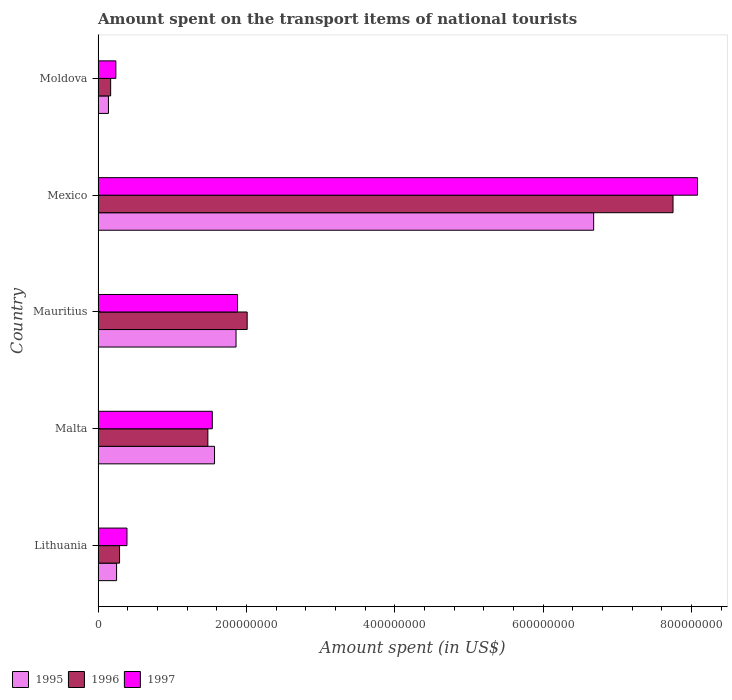How many different coloured bars are there?
Keep it short and to the point. 3. Are the number of bars on each tick of the Y-axis equal?
Offer a very short reply. Yes. How many bars are there on the 1st tick from the bottom?
Offer a very short reply. 3. What is the label of the 4th group of bars from the top?
Offer a terse response. Malta. In how many cases, is the number of bars for a given country not equal to the number of legend labels?
Give a very brief answer. 0. What is the amount spent on the transport items of national tourists in 1997 in Lithuania?
Offer a terse response. 3.90e+07. Across all countries, what is the maximum amount spent on the transport items of national tourists in 1996?
Give a very brief answer. 7.75e+08. Across all countries, what is the minimum amount spent on the transport items of national tourists in 1996?
Your response must be concise. 1.70e+07. In which country was the amount spent on the transport items of national tourists in 1996 minimum?
Your answer should be very brief. Moldova. What is the total amount spent on the transport items of national tourists in 1997 in the graph?
Your answer should be very brief. 1.21e+09. What is the difference between the amount spent on the transport items of national tourists in 1995 in Lithuania and that in Mauritius?
Ensure brevity in your answer.  -1.61e+08. What is the difference between the amount spent on the transport items of national tourists in 1997 in Malta and the amount spent on the transport items of national tourists in 1995 in Lithuania?
Ensure brevity in your answer.  1.29e+08. What is the average amount spent on the transport items of national tourists in 1996 per country?
Give a very brief answer. 2.34e+08. What is the difference between the amount spent on the transport items of national tourists in 1996 and amount spent on the transport items of national tourists in 1997 in Lithuania?
Provide a succinct answer. -1.00e+07. What is the ratio of the amount spent on the transport items of national tourists in 1995 in Malta to that in Moldova?
Offer a very short reply. 11.21. Is the difference between the amount spent on the transport items of national tourists in 1996 in Lithuania and Mexico greater than the difference between the amount spent on the transport items of national tourists in 1997 in Lithuania and Mexico?
Your answer should be compact. Yes. What is the difference between the highest and the second highest amount spent on the transport items of national tourists in 1997?
Your answer should be very brief. 6.20e+08. What is the difference between the highest and the lowest amount spent on the transport items of national tourists in 1997?
Provide a succinct answer. 7.84e+08. In how many countries, is the amount spent on the transport items of national tourists in 1996 greater than the average amount spent on the transport items of national tourists in 1996 taken over all countries?
Offer a very short reply. 1. What does the 3rd bar from the top in Mexico represents?
Make the answer very short. 1995. How many bars are there?
Provide a succinct answer. 15. Are all the bars in the graph horizontal?
Provide a short and direct response. Yes. How many countries are there in the graph?
Keep it short and to the point. 5. Are the values on the major ticks of X-axis written in scientific E-notation?
Make the answer very short. No. Where does the legend appear in the graph?
Your response must be concise. Bottom left. How many legend labels are there?
Keep it short and to the point. 3. What is the title of the graph?
Keep it short and to the point. Amount spent on the transport items of national tourists. What is the label or title of the X-axis?
Keep it short and to the point. Amount spent (in US$). What is the label or title of the Y-axis?
Your answer should be very brief. Country. What is the Amount spent (in US$) of 1995 in Lithuania?
Your answer should be compact. 2.50e+07. What is the Amount spent (in US$) of 1996 in Lithuania?
Offer a very short reply. 2.90e+07. What is the Amount spent (in US$) in 1997 in Lithuania?
Offer a very short reply. 3.90e+07. What is the Amount spent (in US$) of 1995 in Malta?
Your answer should be compact. 1.57e+08. What is the Amount spent (in US$) of 1996 in Malta?
Your response must be concise. 1.48e+08. What is the Amount spent (in US$) in 1997 in Malta?
Offer a terse response. 1.54e+08. What is the Amount spent (in US$) of 1995 in Mauritius?
Keep it short and to the point. 1.86e+08. What is the Amount spent (in US$) in 1996 in Mauritius?
Your answer should be very brief. 2.01e+08. What is the Amount spent (in US$) of 1997 in Mauritius?
Offer a very short reply. 1.88e+08. What is the Amount spent (in US$) in 1995 in Mexico?
Your answer should be very brief. 6.68e+08. What is the Amount spent (in US$) of 1996 in Mexico?
Your response must be concise. 7.75e+08. What is the Amount spent (in US$) in 1997 in Mexico?
Keep it short and to the point. 8.08e+08. What is the Amount spent (in US$) in 1995 in Moldova?
Keep it short and to the point. 1.40e+07. What is the Amount spent (in US$) in 1996 in Moldova?
Keep it short and to the point. 1.70e+07. What is the Amount spent (in US$) in 1997 in Moldova?
Keep it short and to the point. 2.40e+07. Across all countries, what is the maximum Amount spent (in US$) in 1995?
Ensure brevity in your answer.  6.68e+08. Across all countries, what is the maximum Amount spent (in US$) in 1996?
Keep it short and to the point. 7.75e+08. Across all countries, what is the maximum Amount spent (in US$) in 1997?
Ensure brevity in your answer.  8.08e+08. Across all countries, what is the minimum Amount spent (in US$) in 1995?
Your response must be concise. 1.40e+07. Across all countries, what is the minimum Amount spent (in US$) in 1996?
Your response must be concise. 1.70e+07. Across all countries, what is the minimum Amount spent (in US$) in 1997?
Make the answer very short. 2.40e+07. What is the total Amount spent (in US$) of 1995 in the graph?
Offer a very short reply. 1.05e+09. What is the total Amount spent (in US$) in 1996 in the graph?
Ensure brevity in your answer.  1.17e+09. What is the total Amount spent (in US$) of 1997 in the graph?
Keep it short and to the point. 1.21e+09. What is the difference between the Amount spent (in US$) of 1995 in Lithuania and that in Malta?
Offer a very short reply. -1.32e+08. What is the difference between the Amount spent (in US$) in 1996 in Lithuania and that in Malta?
Offer a terse response. -1.19e+08. What is the difference between the Amount spent (in US$) of 1997 in Lithuania and that in Malta?
Give a very brief answer. -1.15e+08. What is the difference between the Amount spent (in US$) of 1995 in Lithuania and that in Mauritius?
Offer a terse response. -1.61e+08. What is the difference between the Amount spent (in US$) in 1996 in Lithuania and that in Mauritius?
Ensure brevity in your answer.  -1.72e+08. What is the difference between the Amount spent (in US$) of 1997 in Lithuania and that in Mauritius?
Your answer should be very brief. -1.49e+08. What is the difference between the Amount spent (in US$) of 1995 in Lithuania and that in Mexico?
Provide a succinct answer. -6.43e+08. What is the difference between the Amount spent (in US$) in 1996 in Lithuania and that in Mexico?
Offer a terse response. -7.46e+08. What is the difference between the Amount spent (in US$) of 1997 in Lithuania and that in Mexico?
Your answer should be very brief. -7.69e+08. What is the difference between the Amount spent (in US$) of 1995 in Lithuania and that in Moldova?
Offer a very short reply. 1.10e+07. What is the difference between the Amount spent (in US$) in 1997 in Lithuania and that in Moldova?
Your answer should be very brief. 1.50e+07. What is the difference between the Amount spent (in US$) of 1995 in Malta and that in Mauritius?
Make the answer very short. -2.90e+07. What is the difference between the Amount spent (in US$) in 1996 in Malta and that in Mauritius?
Ensure brevity in your answer.  -5.30e+07. What is the difference between the Amount spent (in US$) of 1997 in Malta and that in Mauritius?
Give a very brief answer. -3.40e+07. What is the difference between the Amount spent (in US$) in 1995 in Malta and that in Mexico?
Keep it short and to the point. -5.11e+08. What is the difference between the Amount spent (in US$) in 1996 in Malta and that in Mexico?
Offer a terse response. -6.27e+08. What is the difference between the Amount spent (in US$) in 1997 in Malta and that in Mexico?
Offer a very short reply. -6.54e+08. What is the difference between the Amount spent (in US$) of 1995 in Malta and that in Moldova?
Offer a very short reply. 1.43e+08. What is the difference between the Amount spent (in US$) of 1996 in Malta and that in Moldova?
Your answer should be very brief. 1.31e+08. What is the difference between the Amount spent (in US$) of 1997 in Malta and that in Moldova?
Provide a succinct answer. 1.30e+08. What is the difference between the Amount spent (in US$) of 1995 in Mauritius and that in Mexico?
Give a very brief answer. -4.82e+08. What is the difference between the Amount spent (in US$) of 1996 in Mauritius and that in Mexico?
Your answer should be compact. -5.74e+08. What is the difference between the Amount spent (in US$) in 1997 in Mauritius and that in Mexico?
Offer a terse response. -6.20e+08. What is the difference between the Amount spent (in US$) in 1995 in Mauritius and that in Moldova?
Your response must be concise. 1.72e+08. What is the difference between the Amount spent (in US$) of 1996 in Mauritius and that in Moldova?
Give a very brief answer. 1.84e+08. What is the difference between the Amount spent (in US$) of 1997 in Mauritius and that in Moldova?
Your response must be concise. 1.64e+08. What is the difference between the Amount spent (in US$) of 1995 in Mexico and that in Moldova?
Make the answer very short. 6.54e+08. What is the difference between the Amount spent (in US$) of 1996 in Mexico and that in Moldova?
Give a very brief answer. 7.58e+08. What is the difference between the Amount spent (in US$) of 1997 in Mexico and that in Moldova?
Your answer should be very brief. 7.84e+08. What is the difference between the Amount spent (in US$) of 1995 in Lithuania and the Amount spent (in US$) of 1996 in Malta?
Give a very brief answer. -1.23e+08. What is the difference between the Amount spent (in US$) in 1995 in Lithuania and the Amount spent (in US$) in 1997 in Malta?
Give a very brief answer. -1.29e+08. What is the difference between the Amount spent (in US$) of 1996 in Lithuania and the Amount spent (in US$) of 1997 in Malta?
Keep it short and to the point. -1.25e+08. What is the difference between the Amount spent (in US$) of 1995 in Lithuania and the Amount spent (in US$) of 1996 in Mauritius?
Your answer should be compact. -1.76e+08. What is the difference between the Amount spent (in US$) of 1995 in Lithuania and the Amount spent (in US$) of 1997 in Mauritius?
Provide a short and direct response. -1.63e+08. What is the difference between the Amount spent (in US$) in 1996 in Lithuania and the Amount spent (in US$) in 1997 in Mauritius?
Provide a short and direct response. -1.59e+08. What is the difference between the Amount spent (in US$) in 1995 in Lithuania and the Amount spent (in US$) in 1996 in Mexico?
Ensure brevity in your answer.  -7.50e+08. What is the difference between the Amount spent (in US$) of 1995 in Lithuania and the Amount spent (in US$) of 1997 in Mexico?
Your answer should be very brief. -7.83e+08. What is the difference between the Amount spent (in US$) of 1996 in Lithuania and the Amount spent (in US$) of 1997 in Mexico?
Your answer should be compact. -7.79e+08. What is the difference between the Amount spent (in US$) of 1995 in Lithuania and the Amount spent (in US$) of 1996 in Moldova?
Offer a terse response. 8.00e+06. What is the difference between the Amount spent (in US$) in 1996 in Lithuania and the Amount spent (in US$) in 1997 in Moldova?
Keep it short and to the point. 5.00e+06. What is the difference between the Amount spent (in US$) in 1995 in Malta and the Amount spent (in US$) in 1996 in Mauritius?
Provide a succinct answer. -4.40e+07. What is the difference between the Amount spent (in US$) of 1995 in Malta and the Amount spent (in US$) of 1997 in Mauritius?
Make the answer very short. -3.10e+07. What is the difference between the Amount spent (in US$) of 1996 in Malta and the Amount spent (in US$) of 1997 in Mauritius?
Provide a succinct answer. -4.00e+07. What is the difference between the Amount spent (in US$) of 1995 in Malta and the Amount spent (in US$) of 1996 in Mexico?
Give a very brief answer. -6.18e+08. What is the difference between the Amount spent (in US$) in 1995 in Malta and the Amount spent (in US$) in 1997 in Mexico?
Offer a terse response. -6.51e+08. What is the difference between the Amount spent (in US$) of 1996 in Malta and the Amount spent (in US$) of 1997 in Mexico?
Offer a terse response. -6.60e+08. What is the difference between the Amount spent (in US$) of 1995 in Malta and the Amount spent (in US$) of 1996 in Moldova?
Offer a terse response. 1.40e+08. What is the difference between the Amount spent (in US$) in 1995 in Malta and the Amount spent (in US$) in 1997 in Moldova?
Offer a terse response. 1.33e+08. What is the difference between the Amount spent (in US$) of 1996 in Malta and the Amount spent (in US$) of 1997 in Moldova?
Make the answer very short. 1.24e+08. What is the difference between the Amount spent (in US$) in 1995 in Mauritius and the Amount spent (in US$) in 1996 in Mexico?
Offer a very short reply. -5.89e+08. What is the difference between the Amount spent (in US$) of 1995 in Mauritius and the Amount spent (in US$) of 1997 in Mexico?
Offer a terse response. -6.22e+08. What is the difference between the Amount spent (in US$) in 1996 in Mauritius and the Amount spent (in US$) in 1997 in Mexico?
Provide a short and direct response. -6.07e+08. What is the difference between the Amount spent (in US$) of 1995 in Mauritius and the Amount spent (in US$) of 1996 in Moldova?
Give a very brief answer. 1.69e+08. What is the difference between the Amount spent (in US$) in 1995 in Mauritius and the Amount spent (in US$) in 1997 in Moldova?
Provide a succinct answer. 1.62e+08. What is the difference between the Amount spent (in US$) of 1996 in Mauritius and the Amount spent (in US$) of 1997 in Moldova?
Your answer should be compact. 1.77e+08. What is the difference between the Amount spent (in US$) of 1995 in Mexico and the Amount spent (in US$) of 1996 in Moldova?
Provide a succinct answer. 6.51e+08. What is the difference between the Amount spent (in US$) of 1995 in Mexico and the Amount spent (in US$) of 1997 in Moldova?
Your answer should be very brief. 6.44e+08. What is the difference between the Amount spent (in US$) of 1996 in Mexico and the Amount spent (in US$) of 1997 in Moldova?
Provide a succinct answer. 7.51e+08. What is the average Amount spent (in US$) in 1995 per country?
Make the answer very short. 2.10e+08. What is the average Amount spent (in US$) in 1996 per country?
Your answer should be very brief. 2.34e+08. What is the average Amount spent (in US$) of 1997 per country?
Give a very brief answer. 2.43e+08. What is the difference between the Amount spent (in US$) in 1995 and Amount spent (in US$) in 1997 in Lithuania?
Make the answer very short. -1.40e+07. What is the difference between the Amount spent (in US$) of 1996 and Amount spent (in US$) of 1997 in Lithuania?
Your answer should be very brief. -1.00e+07. What is the difference between the Amount spent (in US$) of 1995 and Amount spent (in US$) of 1996 in Malta?
Give a very brief answer. 9.00e+06. What is the difference between the Amount spent (in US$) of 1995 and Amount spent (in US$) of 1997 in Malta?
Offer a terse response. 3.00e+06. What is the difference between the Amount spent (in US$) in 1996 and Amount spent (in US$) in 1997 in Malta?
Your response must be concise. -6.00e+06. What is the difference between the Amount spent (in US$) in 1995 and Amount spent (in US$) in 1996 in Mauritius?
Your answer should be very brief. -1.50e+07. What is the difference between the Amount spent (in US$) of 1995 and Amount spent (in US$) of 1997 in Mauritius?
Provide a short and direct response. -2.00e+06. What is the difference between the Amount spent (in US$) of 1996 and Amount spent (in US$) of 1997 in Mauritius?
Your response must be concise. 1.30e+07. What is the difference between the Amount spent (in US$) of 1995 and Amount spent (in US$) of 1996 in Mexico?
Provide a short and direct response. -1.07e+08. What is the difference between the Amount spent (in US$) of 1995 and Amount spent (in US$) of 1997 in Mexico?
Your answer should be compact. -1.40e+08. What is the difference between the Amount spent (in US$) of 1996 and Amount spent (in US$) of 1997 in Mexico?
Make the answer very short. -3.30e+07. What is the difference between the Amount spent (in US$) of 1995 and Amount spent (in US$) of 1996 in Moldova?
Your response must be concise. -3.00e+06. What is the difference between the Amount spent (in US$) in 1995 and Amount spent (in US$) in 1997 in Moldova?
Your answer should be very brief. -1.00e+07. What is the difference between the Amount spent (in US$) of 1996 and Amount spent (in US$) of 1997 in Moldova?
Provide a short and direct response. -7.00e+06. What is the ratio of the Amount spent (in US$) of 1995 in Lithuania to that in Malta?
Offer a very short reply. 0.16. What is the ratio of the Amount spent (in US$) in 1996 in Lithuania to that in Malta?
Offer a terse response. 0.2. What is the ratio of the Amount spent (in US$) of 1997 in Lithuania to that in Malta?
Make the answer very short. 0.25. What is the ratio of the Amount spent (in US$) in 1995 in Lithuania to that in Mauritius?
Make the answer very short. 0.13. What is the ratio of the Amount spent (in US$) of 1996 in Lithuania to that in Mauritius?
Provide a short and direct response. 0.14. What is the ratio of the Amount spent (in US$) of 1997 in Lithuania to that in Mauritius?
Provide a short and direct response. 0.21. What is the ratio of the Amount spent (in US$) in 1995 in Lithuania to that in Mexico?
Keep it short and to the point. 0.04. What is the ratio of the Amount spent (in US$) in 1996 in Lithuania to that in Mexico?
Make the answer very short. 0.04. What is the ratio of the Amount spent (in US$) of 1997 in Lithuania to that in Mexico?
Provide a succinct answer. 0.05. What is the ratio of the Amount spent (in US$) in 1995 in Lithuania to that in Moldova?
Your answer should be compact. 1.79. What is the ratio of the Amount spent (in US$) of 1996 in Lithuania to that in Moldova?
Your response must be concise. 1.71. What is the ratio of the Amount spent (in US$) of 1997 in Lithuania to that in Moldova?
Offer a terse response. 1.62. What is the ratio of the Amount spent (in US$) in 1995 in Malta to that in Mauritius?
Ensure brevity in your answer.  0.84. What is the ratio of the Amount spent (in US$) in 1996 in Malta to that in Mauritius?
Your answer should be very brief. 0.74. What is the ratio of the Amount spent (in US$) in 1997 in Malta to that in Mauritius?
Ensure brevity in your answer.  0.82. What is the ratio of the Amount spent (in US$) in 1995 in Malta to that in Mexico?
Provide a short and direct response. 0.23. What is the ratio of the Amount spent (in US$) in 1996 in Malta to that in Mexico?
Provide a short and direct response. 0.19. What is the ratio of the Amount spent (in US$) of 1997 in Malta to that in Mexico?
Make the answer very short. 0.19. What is the ratio of the Amount spent (in US$) of 1995 in Malta to that in Moldova?
Provide a short and direct response. 11.21. What is the ratio of the Amount spent (in US$) of 1996 in Malta to that in Moldova?
Provide a short and direct response. 8.71. What is the ratio of the Amount spent (in US$) of 1997 in Malta to that in Moldova?
Provide a short and direct response. 6.42. What is the ratio of the Amount spent (in US$) in 1995 in Mauritius to that in Mexico?
Offer a terse response. 0.28. What is the ratio of the Amount spent (in US$) of 1996 in Mauritius to that in Mexico?
Give a very brief answer. 0.26. What is the ratio of the Amount spent (in US$) in 1997 in Mauritius to that in Mexico?
Your answer should be compact. 0.23. What is the ratio of the Amount spent (in US$) of 1995 in Mauritius to that in Moldova?
Keep it short and to the point. 13.29. What is the ratio of the Amount spent (in US$) of 1996 in Mauritius to that in Moldova?
Your answer should be very brief. 11.82. What is the ratio of the Amount spent (in US$) of 1997 in Mauritius to that in Moldova?
Provide a succinct answer. 7.83. What is the ratio of the Amount spent (in US$) in 1995 in Mexico to that in Moldova?
Provide a succinct answer. 47.71. What is the ratio of the Amount spent (in US$) of 1996 in Mexico to that in Moldova?
Your response must be concise. 45.59. What is the ratio of the Amount spent (in US$) of 1997 in Mexico to that in Moldova?
Offer a terse response. 33.67. What is the difference between the highest and the second highest Amount spent (in US$) in 1995?
Keep it short and to the point. 4.82e+08. What is the difference between the highest and the second highest Amount spent (in US$) in 1996?
Your answer should be very brief. 5.74e+08. What is the difference between the highest and the second highest Amount spent (in US$) of 1997?
Keep it short and to the point. 6.20e+08. What is the difference between the highest and the lowest Amount spent (in US$) of 1995?
Keep it short and to the point. 6.54e+08. What is the difference between the highest and the lowest Amount spent (in US$) in 1996?
Your response must be concise. 7.58e+08. What is the difference between the highest and the lowest Amount spent (in US$) of 1997?
Your response must be concise. 7.84e+08. 